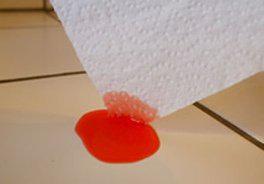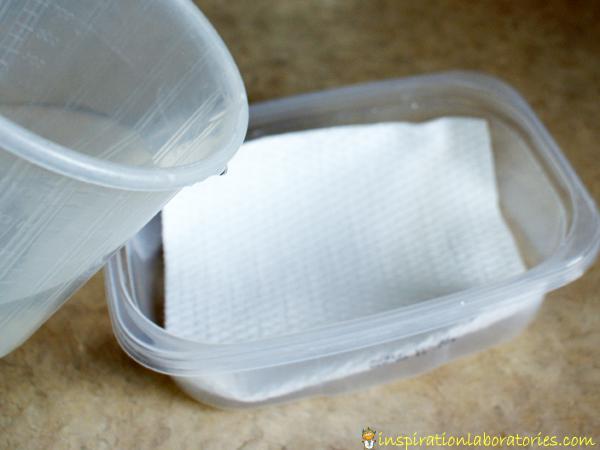The first image is the image on the left, the second image is the image on the right. Given the left and right images, does the statement "One image shows a paper towel dipped in at least one colored liquid, and the other image includes a glass of clear liquid and a paper towel." hold true? Answer yes or no. Yes. The first image is the image on the left, the second image is the image on the right. Analyze the images presented: Is the assertion "A paper towel is soaking in liquid in at least to glasses." valid? Answer yes or no. No. 